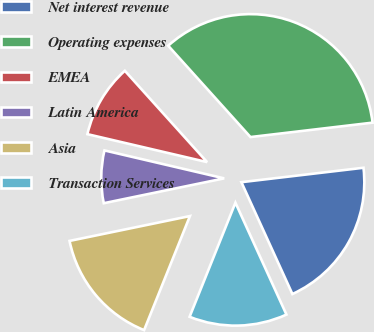Convert chart to OTSL. <chart><loc_0><loc_0><loc_500><loc_500><pie_chart><fcel>Net interest revenue<fcel>Operating expenses<fcel>EMEA<fcel>Latin America<fcel>Asia<fcel>Transaction Services<nl><fcel>20.06%<fcel>34.8%<fcel>9.68%<fcel>6.89%<fcel>15.68%<fcel>12.89%<nl></chart> 